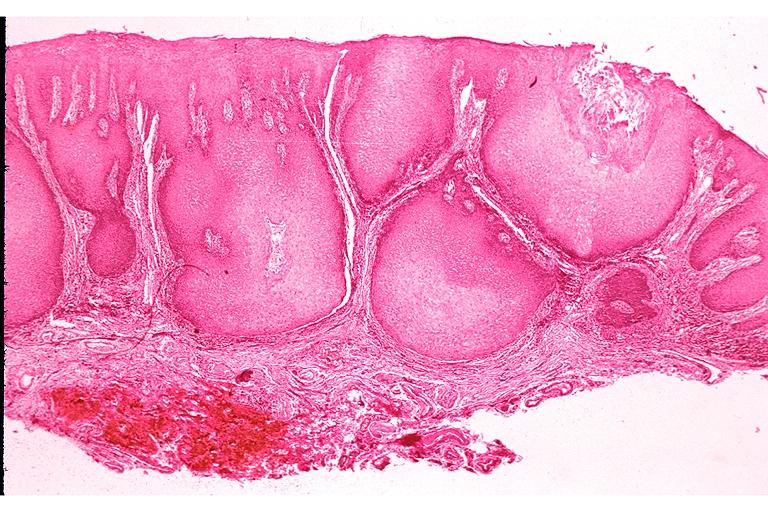what is present?
Answer the question using a single word or phrase. Oral 